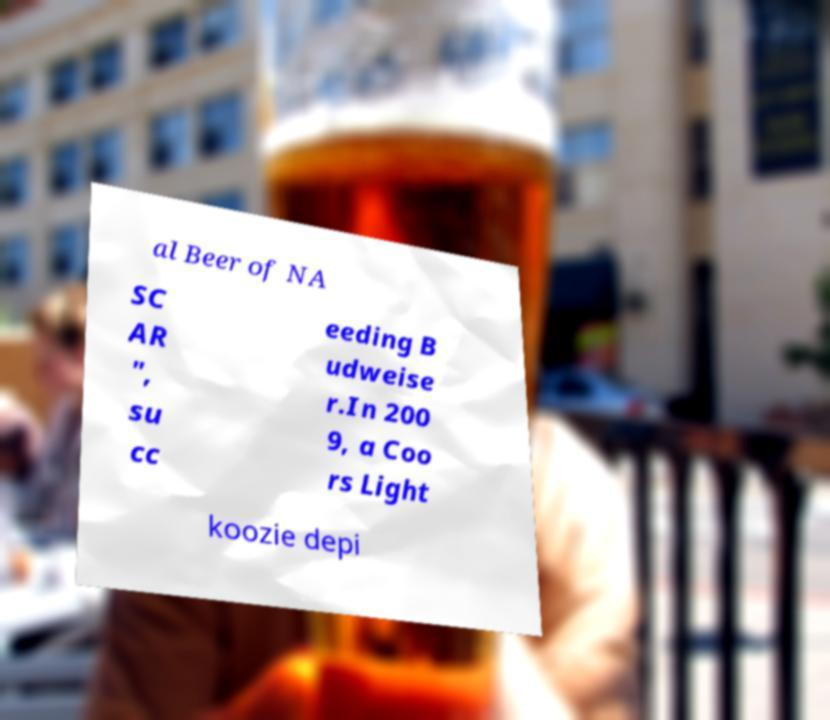For documentation purposes, I need the text within this image transcribed. Could you provide that? al Beer of NA SC AR ", su cc eeding B udweise r.In 200 9, a Coo rs Light koozie depi 